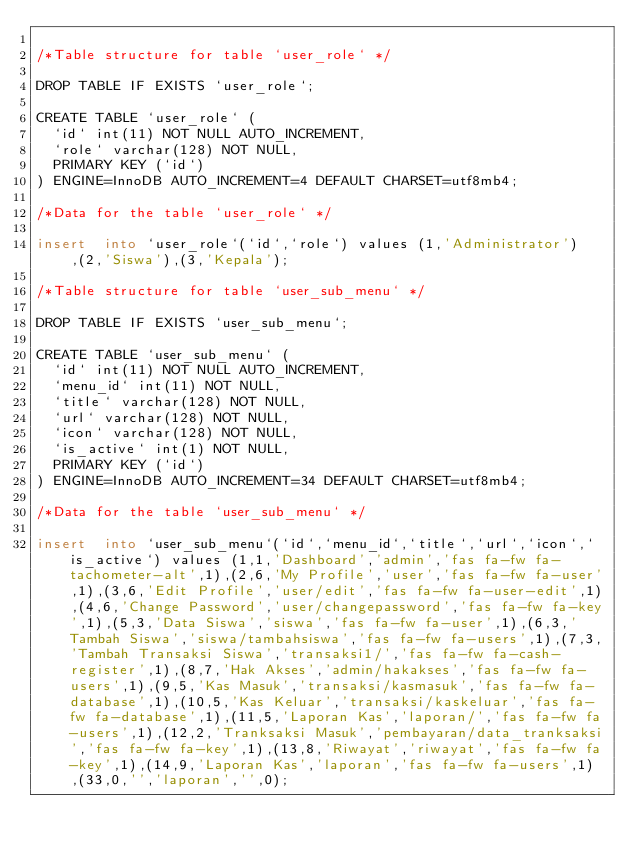Convert code to text. <code><loc_0><loc_0><loc_500><loc_500><_SQL_>
/*Table structure for table `user_role` */

DROP TABLE IF EXISTS `user_role`;

CREATE TABLE `user_role` (
  `id` int(11) NOT NULL AUTO_INCREMENT,
  `role` varchar(128) NOT NULL,
  PRIMARY KEY (`id`)
) ENGINE=InnoDB AUTO_INCREMENT=4 DEFAULT CHARSET=utf8mb4;

/*Data for the table `user_role` */

insert  into `user_role`(`id`,`role`) values (1,'Administrator'),(2,'Siswa'),(3,'Kepala');

/*Table structure for table `user_sub_menu` */

DROP TABLE IF EXISTS `user_sub_menu`;

CREATE TABLE `user_sub_menu` (
  `id` int(11) NOT NULL AUTO_INCREMENT,
  `menu_id` int(11) NOT NULL,
  `title` varchar(128) NOT NULL,
  `url` varchar(128) NOT NULL,
  `icon` varchar(128) NOT NULL,
  `is_active` int(1) NOT NULL,
  PRIMARY KEY (`id`)
) ENGINE=InnoDB AUTO_INCREMENT=34 DEFAULT CHARSET=utf8mb4;

/*Data for the table `user_sub_menu` */

insert  into `user_sub_menu`(`id`,`menu_id`,`title`,`url`,`icon`,`is_active`) values (1,1,'Dashboard','admin','fas fa-fw fa-tachometer-alt',1),(2,6,'My Profile','user','fas fa-fw fa-user',1),(3,6,'Edit Profile','user/edit','fas fa-fw fa-user-edit',1),(4,6,'Change Password','user/changepassword','fas fa-fw fa-key',1),(5,3,'Data Siswa','siswa','fas fa-fw fa-user',1),(6,3,'Tambah Siswa','siswa/tambahsiswa','fas fa-fw fa-users',1),(7,3,'Tambah Transaksi Siswa','transaksi1/','fas fa-fw fa-cash-register',1),(8,7,'Hak Akses','admin/hakakses','fas fa-fw fa-users',1),(9,5,'Kas Masuk','transaksi/kasmasuk','fas fa-fw fa-database',1),(10,5,'Kas Keluar','transaksi/kaskeluar','fas fa-fw fa-database',1),(11,5,'Laporan Kas','laporan/','fas fa-fw fa-users',1),(12,2,'Tranksaksi Masuk','pembayaran/data_tranksaksi','fas fa-fw fa-key',1),(13,8,'Riwayat','riwayat','fas fa-fw fa-key',1),(14,9,'Laporan Kas','laporan','fas fa-fw fa-users',1),(33,0,'','laporan','',0);
</code> 